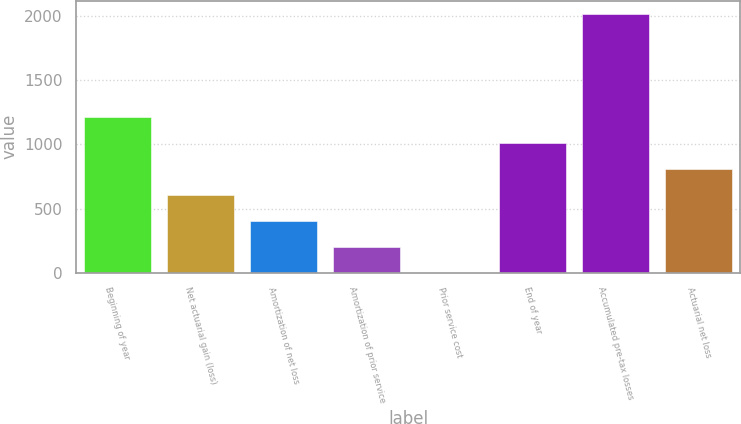Convert chart. <chart><loc_0><loc_0><loc_500><loc_500><bar_chart><fcel>Beginning of year<fcel>Net actuarial gain (loss)<fcel>Amortization of net loss<fcel>Amortization of prior service<fcel>Prior service cost<fcel>End of year<fcel>Accumulated pre-tax losses<fcel>Actuarial net loss<nl><fcel>1211.2<fcel>606.1<fcel>404.4<fcel>202.7<fcel>1<fcel>1009.5<fcel>2018<fcel>807.8<nl></chart> 